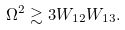<formula> <loc_0><loc_0><loc_500><loc_500>\Omega ^ { 2 } \gtrsim 3 W _ { 1 2 } W _ { 1 3 } .</formula> 